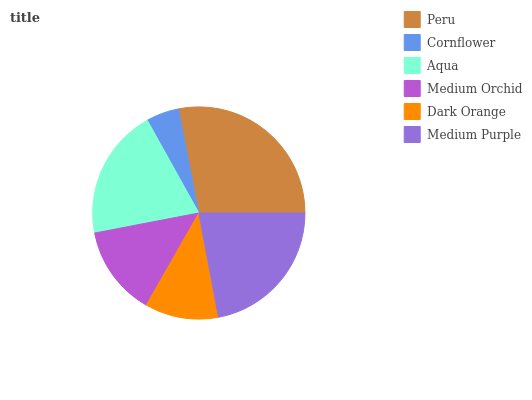Is Cornflower the minimum?
Answer yes or no. Yes. Is Peru the maximum?
Answer yes or no. Yes. Is Aqua the minimum?
Answer yes or no. No. Is Aqua the maximum?
Answer yes or no. No. Is Aqua greater than Cornflower?
Answer yes or no. Yes. Is Cornflower less than Aqua?
Answer yes or no. Yes. Is Cornflower greater than Aqua?
Answer yes or no. No. Is Aqua less than Cornflower?
Answer yes or no. No. Is Aqua the high median?
Answer yes or no. Yes. Is Medium Orchid the low median?
Answer yes or no. Yes. Is Cornflower the high median?
Answer yes or no. No. Is Aqua the low median?
Answer yes or no. No. 